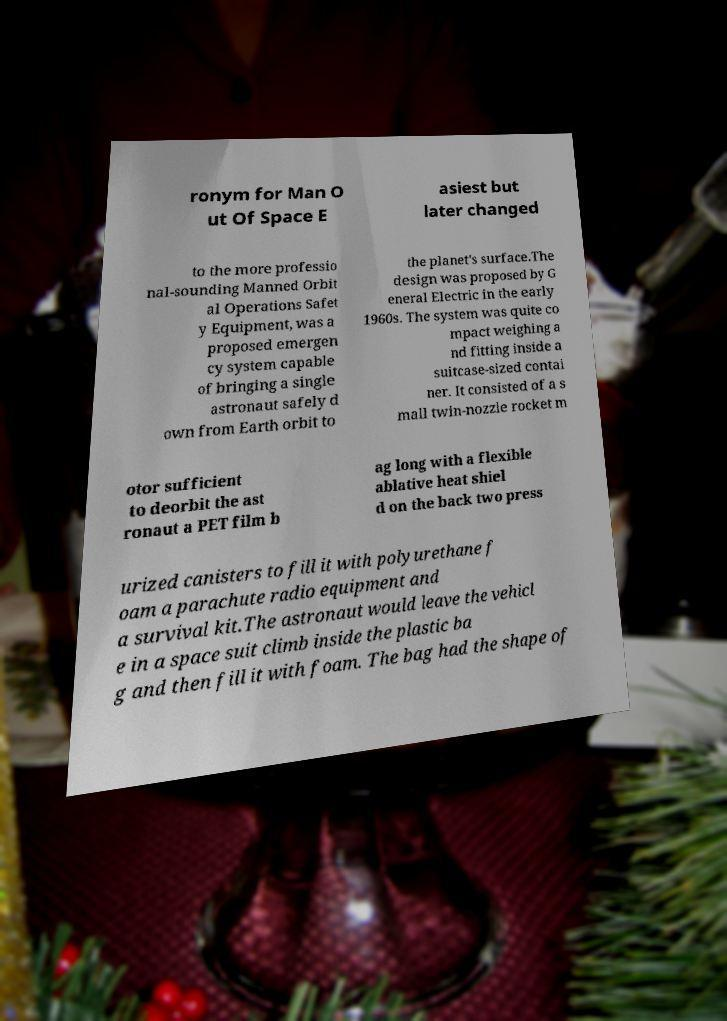Can you read and provide the text displayed in the image?This photo seems to have some interesting text. Can you extract and type it out for me? ronym for Man O ut Of Space E asiest but later changed to the more professio nal-sounding Manned Orbit al Operations Safet y Equipment, was a proposed emergen cy system capable of bringing a single astronaut safely d own from Earth orbit to the planet's surface.The design was proposed by G eneral Electric in the early 1960s. The system was quite co mpact weighing a nd fitting inside a suitcase-sized contai ner. It consisted of a s mall twin-nozzle rocket m otor sufficient to deorbit the ast ronaut a PET film b ag long with a flexible ablative heat shiel d on the back two press urized canisters to fill it with polyurethane f oam a parachute radio equipment and a survival kit.The astronaut would leave the vehicl e in a space suit climb inside the plastic ba g and then fill it with foam. The bag had the shape of 